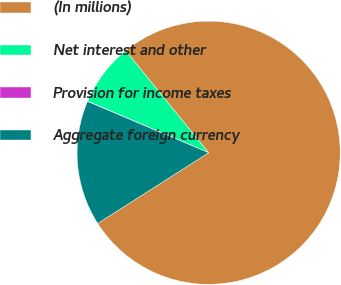Convert chart. <chart><loc_0><loc_0><loc_500><loc_500><pie_chart><fcel>(In millions)<fcel>Net interest and other<fcel>Provision for income taxes<fcel>Aggregate foreign currency<nl><fcel>76.84%<fcel>7.72%<fcel>0.04%<fcel>15.4%<nl></chart> 